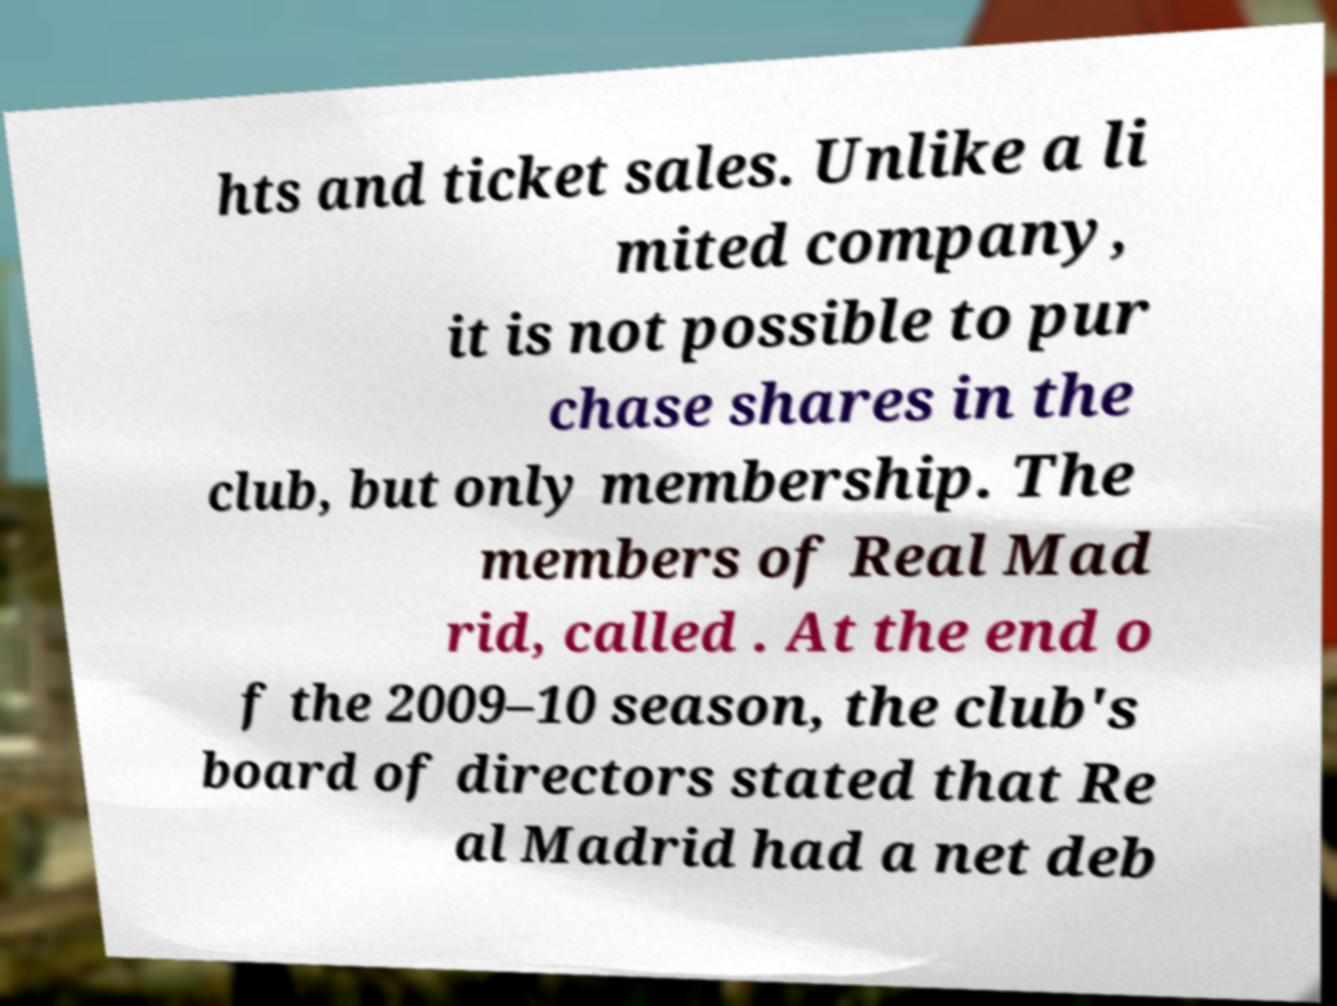Please read and relay the text visible in this image. What does it say? hts and ticket sales. Unlike a li mited company, it is not possible to pur chase shares in the club, but only membership. The members of Real Mad rid, called . At the end o f the 2009–10 season, the club's board of directors stated that Re al Madrid had a net deb 